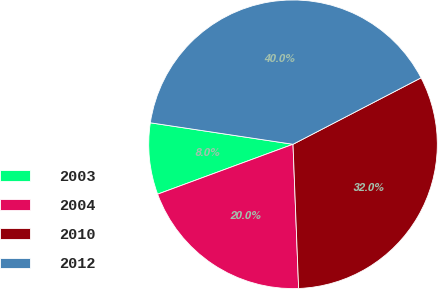Convert chart to OTSL. <chart><loc_0><loc_0><loc_500><loc_500><pie_chart><fcel>2003<fcel>2004<fcel>2010<fcel>2012<nl><fcel>8.0%<fcel>20.0%<fcel>32.0%<fcel>40.0%<nl></chart> 